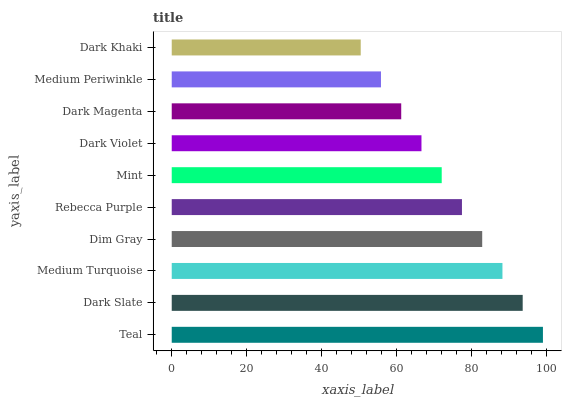Is Dark Khaki the minimum?
Answer yes or no. Yes. Is Teal the maximum?
Answer yes or no. Yes. Is Dark Slate the minimum?
Answer yes or no. No. Is Dark Slate the maximum?
Answer yes or no. No. Is Teal greater than Dark Slate?
Answer yes or no. Yes. Is Dark Slate less than Teal?
Answer yes or no. Yes. Is Dark Slate greater than Teal?
Answer yes or no. No. Is Teal less than Dark Slate?
Answer yes or no. No. Is Rebecca Purple the high median?
Answer yes or no. Yes. Is Mint the low median?
Answer yes or no. Yes. Is Mint the high median?
Answer yes or no. No. Is Teal the low median?
Answer yes or no. No. 